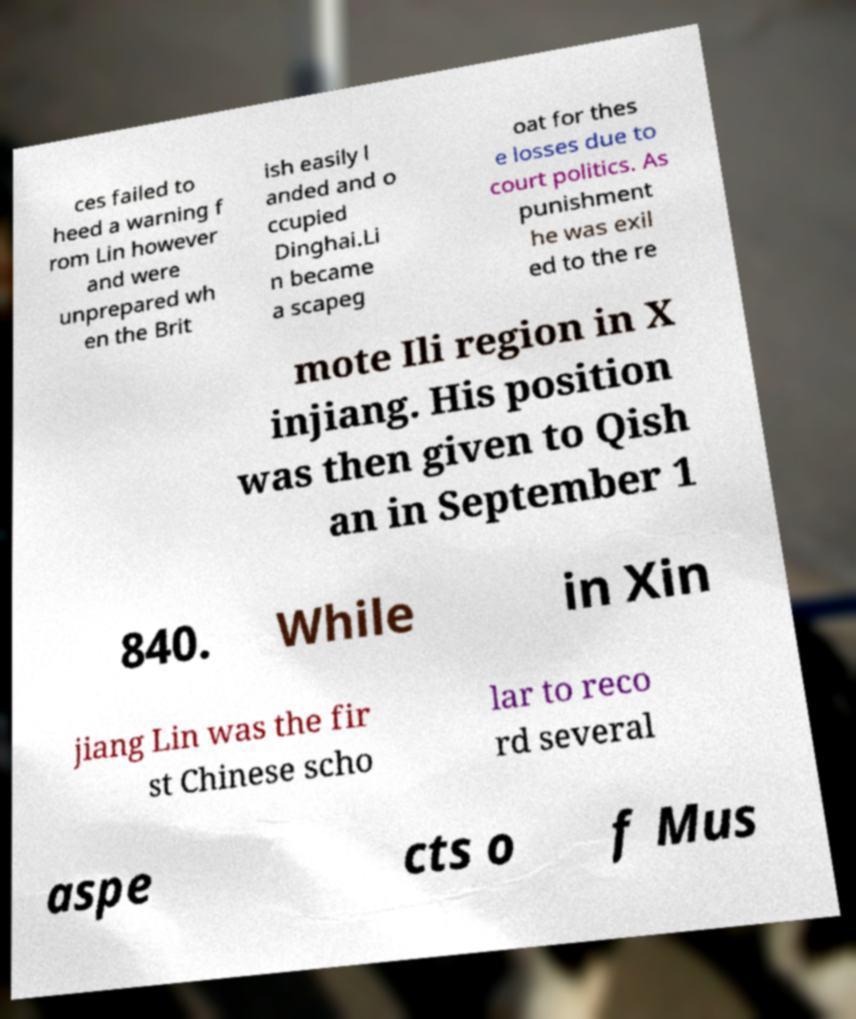What messages or text are displayed in this image? I need them in a readable, typed format. ces failed to heed a warning f rom Lin however and were unprepared wh en the Brit ish easily l anded and o ccupied Dinghai.Li n became a scapeg oat for thes e losses due to court politics. As punishment he was exil ed to the re mote Ili region in X injiang. His position was then given to Qish an in September 1 840. While in Xin jiang Lin was the fir st Chinese scho lar to reco rd several aspe cts o f Mus 